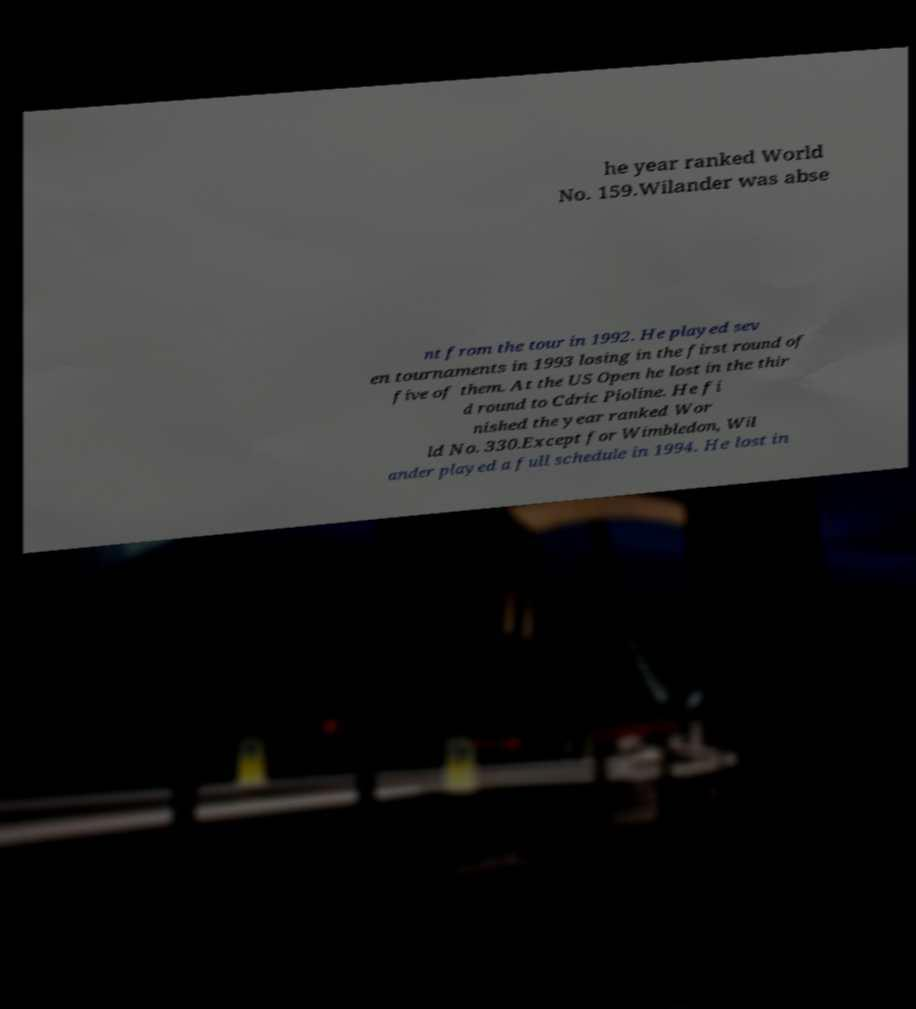Please identify and transcribe the text found in this image. he year ranked World No. 159.Wilander was abse nt from the tour in 1992. He played sev en tournaments in 1993 losing in the first round of five of them. At the US Open he lost in the thir d round to Cdric Pioline. He fi nished the year ranked Wor ld No. 330.Except for Wimbledon, Wil ander played a full schedule in 1994. He lost in 